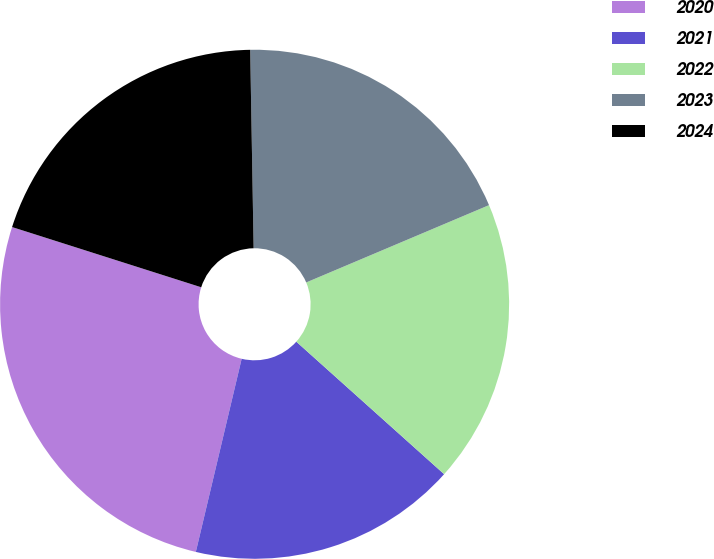<chart> <loc_0><loc_0><loc_500><loc_500><pie_chart><fcel>2020<fcel>2021<fcel>2022<fcel>2023<fcel>2024<nl><fcel>26.2%<fcel>17.08%<fcel>18.0%<fcel>18.91%<fcel>19.82%<nl></chart> 